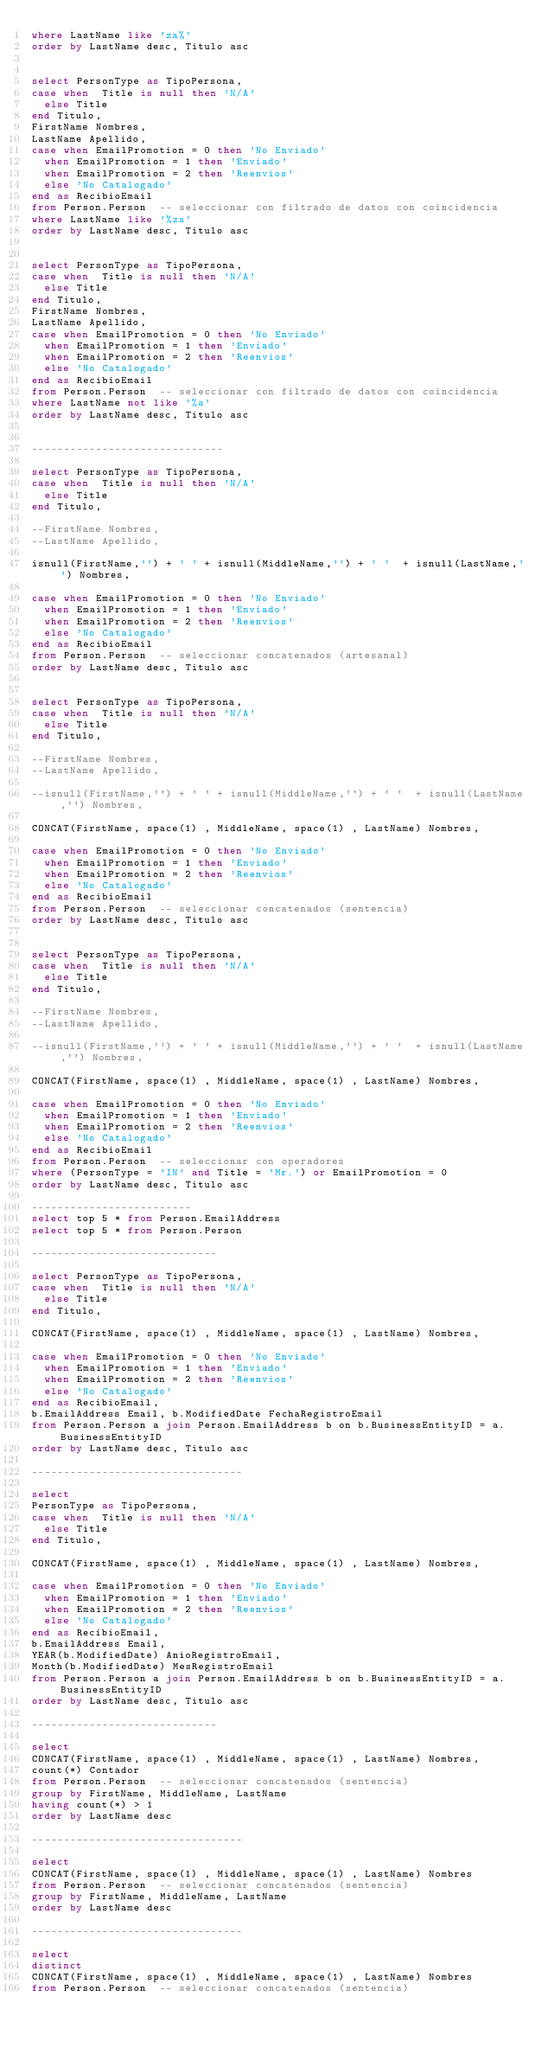Convert code to text. <code><loc_0><loc_0><loc_500><loc_500><_SQL_>where LastName like 'za%'
order by LastName desc, Titulo asc


select PersonType as TipoPersona, 
case when  Title is null then 'N/A'
	else Title
end Titulo, 
FirstName Nombres, 
LastName Apellido, 
case when EmailPromotion = 0 then 'No Enviado'  
	when EmailPromotion = 1 then 'Enviado'
	when EmailPromotion = 2 then 'Reenvios'
	else 'No Catalogado'
end as RecibioEmail 
from Person.Person  -- seleccionar con filtrado de datos con coincidencia
where LastName like '%za'
order by LastName desc, Titulo asc


select PersonType as TipoPersona, 
case when  Title is null then 'N/A'
	else Title
end Titulo, 
FirstName Nombres, 
LastName Apellido, 
case when EmailPromotion = 0 then 'No Enviado'  
	when EmailPromotion = 1 then 'Enviado'
	when EmailPromotion = 2 then 'Reenvios'
	else 'No Catalogado'
end as RecibioEmail 
from Person.Person  -- seleccionar con filtrado de datos con coincidencia
where LastName not like '%a'
order by LastName desc, Titulo asc


------------------------------

select PersonType as TipoPersona, 
case when  Title is null then 'N/A'
	else Title
end Titulo, 

--FirstName Nombres, 
--LastName Apellido, 

isnull(FirstName,'') + ' ' + isnull(MiddleName,'') + ' '  + isnull(LastName,'') Nombres,

case when EmailPromotion = 0 then 'No Enviado'  
	when EmailPromotion = 1 then 'Enviado'
	when EmailPromotion = 2 then 'Reenvios'
	else 'No Catalogado'
end as RecibioEmail 
from Person.Person  -- seleccionar concatenados (artesanal)
order by LastName desc, Titulo asc


select PersonType as TipoPersona, 
case when  Title is null then 'N/A'
	else Title
end Titulo, 

--FirstName Nombres, 
--LastName Apellido, 

--isnull(FirstName,'') + ' ' + isnull(MiddleName,'') + ' '  + isnull(LastName,'') Nombres,

CONCAT(FirstName, space(1) , MiddleName, space(1) , LastName) Nombres,

case when EmailPromotion = 0 then 'No Enviado'  
	when EmailPromotion = 1 then 'Enviado'
	when EmailPromotion = 2 then 'Reenvios'
	else 'No Catalogado'
end as RecibioEmail 
from Person.Person  -- seleccionar concatenados (sentencia)
order by LastName desc, Titulo asc


select PersonType as TipoPersona, 
case when  Title is null then 'N/A'
	else Title
end Titulo, 

--FirstName Nombres, 
--LastName Apellido, 

--isnull(FirstName,'') + ' ' + isnull(MiddleName,'') + ' '  + isnull(LastName,'') Nombres,

CONCAT(FirstName, space(1) , MiddleName, space(1) , LastName) Nombres,

case when EmailPromotion = 0 then 'No Enviado'  
	when EmailPromotion = 1 then 'Enviado'
	when EmailPromotion = 2 then 'Reenvios'
	else 'No Catalogado'
end as RecibioEmail 
from Person.Person  -- seleccionar con operadores
where (PersonType = 'IN' and Title = 'Mr.') or EmailPromotion = 0
order by LastName desc, Titulo asc

-------------------------
select top 5 * from Person.EmailAddress
select top 5 * from Person.Person

-----------------------------

select PersonType as TipoPersona, 
case when  Title is null then 'N/A'
	else Title
end Titulo, 

CONCAT(FirstName, space(1) , MiddleName, space(1) , LastName) Nombres,

case when EmailPromotion = 0 then 'No Enviado'  
	when EmailPromotion = 1 then 'Enviado'
	when EmailPromotion = 2 then 'Reenvios'
	else 'No Catalogado'
end as RecibioEmail, 
b.EmailAddress Email, b.ModifiedDate FechaRegistroEmail
from Person.Person a join Person.EmailAddress b on b.BusinessEntityID = a.BusinessEntityID
order by LastName desc, Titulo asc

---------------------------------

select 
PersonType as TipoPersona, 
case when  Title is null then 'N/A'
	else Title
end Titulo, 

CONCAT(FirstName, space(1) , MiddleName, space(1) , LastName) Nombres,

case when EmailPromotion = 0 then 'No Enviado'  
	when EmailPromotion = 1 then 'Enviado'
	when EmailPromotion = 2 then 'Reenvios'
	else 'No Catalogado'
end as RecibioEmail, 
b.EmailAddress Email, 
YEAR(b.ModifiedDate) AnioRegistroEmail,
Month(b.ModifiedDate) MesRegistroEmail
from Person.Person a join Person.EmailAddress b on b.BusinessEntityID = a.BusinessEntityID
order by LastName desc, Titulo asc

-----------------------------

select 
CONCAT(FirstName, space(1) , MiddleName, space(1) , LastName) Nombres,
count(*) Contador 
from Person.Person  -- seleccionar concatenados (sentencia)
group by FirstName, MiddleName, LastName
having count(*) > 1
order by LastName desc

---------------------------------

select 
CONCAT(FirstName, space(1) , MiddleName, space(1) , LastName) Nombres
from Person.Person  -- seleccionar concatenados (sentencia)
group by FirstName, MiddleName, LastName
order by LastName desc

---------------------------------

select 
distinct
CONCAT(FirstName, space(1) , MiddleName, space(1) , LastName) Nombres
from Person.Person  -- seleccionar concatenados (sentencia)

</code> 